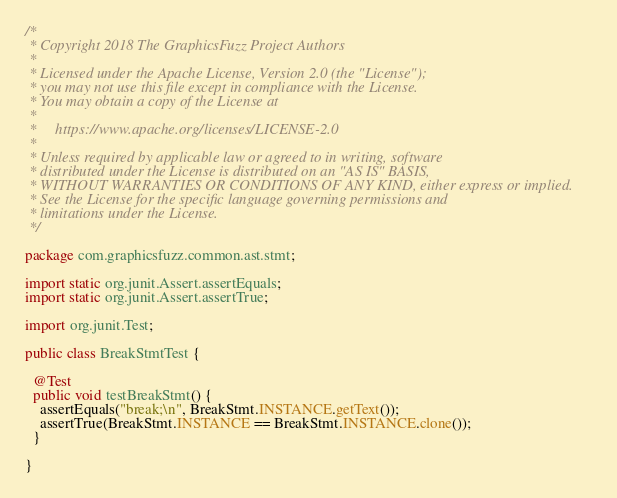Convert code to text. <code><loc_0><loc_0><loc_500><loc_500><_Java_>/*
 * Copyright 2018 The GraphicsFuzz Project Authors
 *
 * Licensed under the Apache License, Version 2.0 (the "License");
 * you may not use this file except in compliance with the License.
 * You may obtain a copy of the License at
 *
 *     https://www.apache.org/licenses/LICENSE-2.0
 *
 * Unless required by applicable law or agreed to in writing, software
 * distributed under the License is distributed on an "AS IS" BASIS,
 * WITHOUT WARRANTIES OR CONDITIONS OF ANY KIND, either express or implied.
 * See the License for the specific language governing permissions and
 * limitations under the License.
 */

package com.graphicsfuzz.common.ast.stmt;

import static org.junit.Assert.assertEquals;
import static org.junit.Assert.assertTrue;

import org.junit.Test;

public class BreakStmtTest {

  @Test
  public void testBreakStmt() {
    assertEquals("break;\n", BreakStmt.INSTANCE.getText());
    assertTrue(BreakStmt.INSTANCE == BreakStmt.INSTANCE.clone());
  }

}</code> 